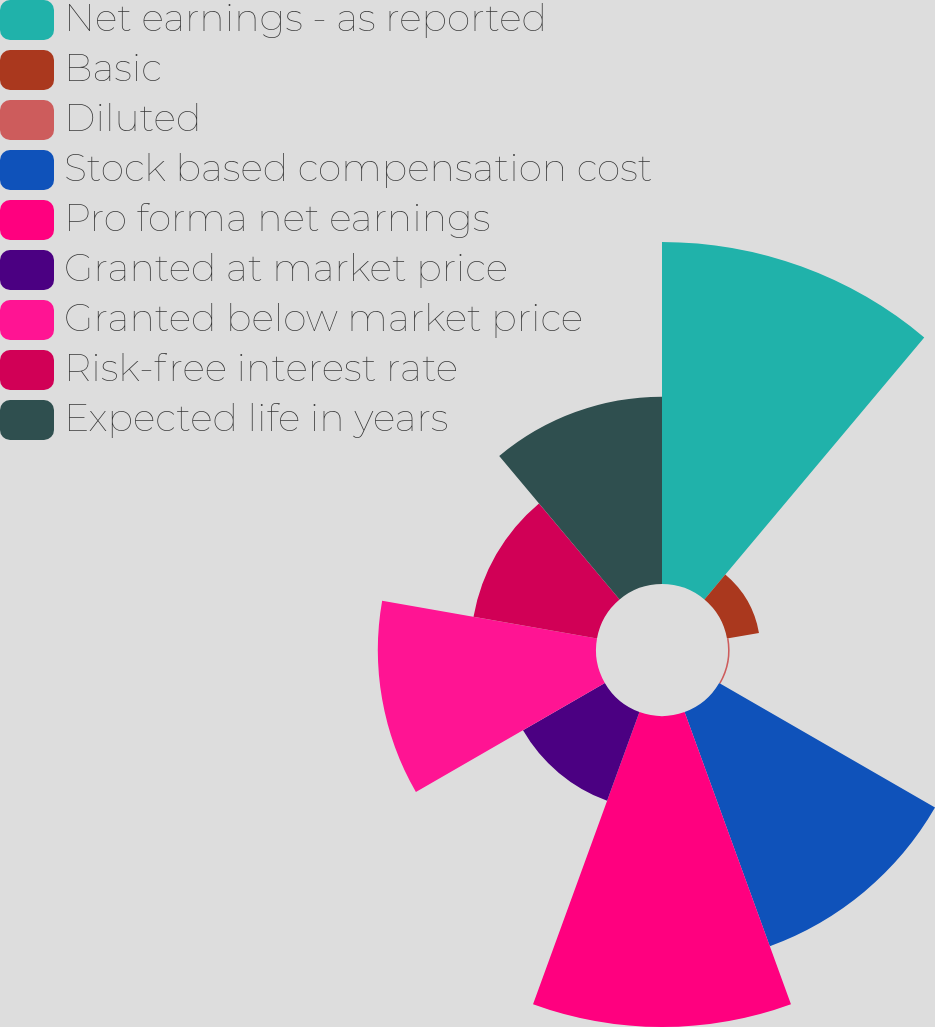Convert chart to OTSL. <chart><loc_0><loc_0><loc_500><loc_500><pie_chart><fcel>Net earnings - as reported<fcel>Basic<fcel>Diluted<fcel>Stock based compensation cost<fcel>Pro forma net earnings<fcel>Granted at market price<fcel>Granted below market price<fcel>Risk-free interest rate<fcel>Expected life in years<nl><fcel>21.9%<fcel>2.08%<fcel>0.1%<fcel>15.96%<fcel>19.92%<fcel>6.05%<fcel>13.97%<fcel>8.03%<fcel>11.99%<nl></chart> 